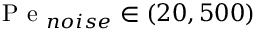<formula> <loc_0><loc_0><loc_500><loc_500>P e _ { n o i s e } \in ( 2 0 , 5 0 0 )</formula> 